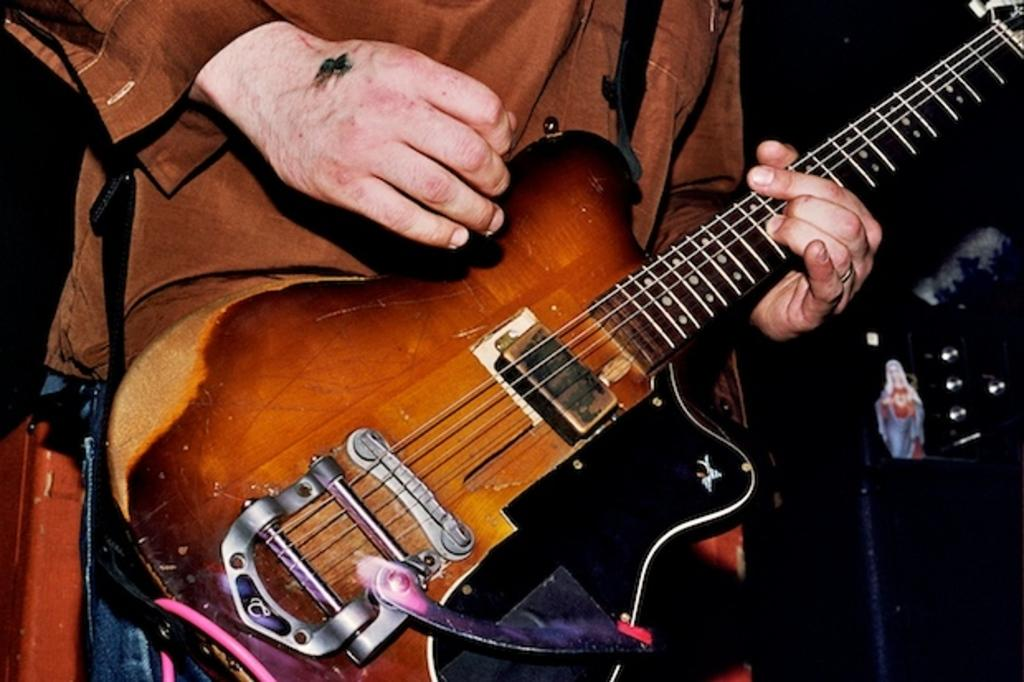What is the main subject of the image? The main subject of the image is a man. What is the man doing in the image? The man is standing and playing a guitar. Are there any additional features on the guitar? Yes, there is an idol on the guitar. What type of bait is the man using to catch fish in the image? There is no indication in the image that the man is fishing or using bait; he is playing a guitar. What is the man eating for breakfast in the image? There is no indication in the image that the man is eating breakfast; he is playing a guitar. 